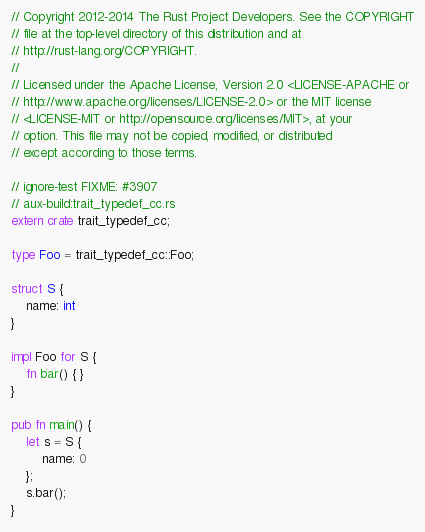<code> <loc_0><loc_0><loc_500><loc_500><_Rust_>// Copyright 2012-2014 The Rust Project Developers. See the COPYRIGHT
// file at the top-level directory of this distribution and at
// http://rust-lang.org/COPYRIGHT.
//
// Licensed under the Apache License, Version 2.0 <LICENSE-APACHE or
// http://www.apache.org/licenses/LICENSE-2.0> or the MIT license
// <LICENSE-MIT or http://opensource.org/licenses/MIT>, at your
// option. This file may not be copied, modified, or distributed
// except according to those terms.

// ignore-test FIXME: #3907
// aux-build:trait_typedef_cc.rs
extern crate trait_typedef_cc;

type Foo = trait_typedef_cc::Foo;

struct S {
    name: int
}

impl Foo for S {
    fn bar() { }
}

pub fn main() {
    let s = S {
        name: 0
    };
    s.bar();
}
</code> 